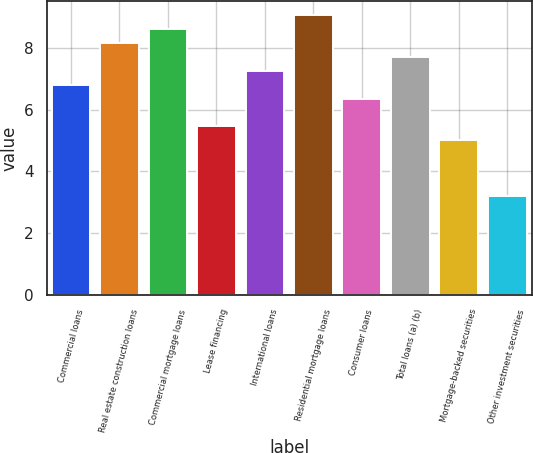<chart> <loc_0><loc_0><loc_500><loc_500><bar_chart><fcel>Commercial loans<fcel>Real estate construction loans<fcel>Commercial mortgage loans<fcel>Lease financing<fcel>International loans<fcel>Residential mortgage loans<fcel>Consumer loans<fcel>Total loans (a) (b)<fcel>Mortgage-backed securities<fcel>Other investment securities<nl><fcel>6.81<fcel>8.16<fcel>8.61<fcel>5.46<fcel>7.26<fcel>9.06<fcel>6.36<fcel>7.71<fcel>5.01<fcel>3.21<nl></chart> 